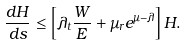<formula> <loc_0><loc_0><loc_500><loc_500>\frac { d H } { d s } \leq \left [ \lambda _ { t } \frac { W } { E } + \mu _ { r } e ^ { \mu - \lambda } \right ] H .</formula> 